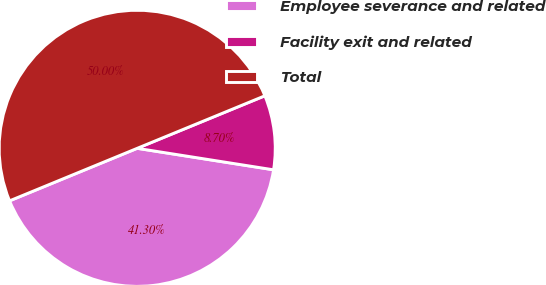Convert chart. <chart><loc_0><loc_0><loc_500><loc_500><pie_chart><fcel>Employee severance and related<fcel>Facility exit and related<fcel>Total<nl><fcel>41.3%<fcel>8.7%<fcel>50.0%<nl></chart> 